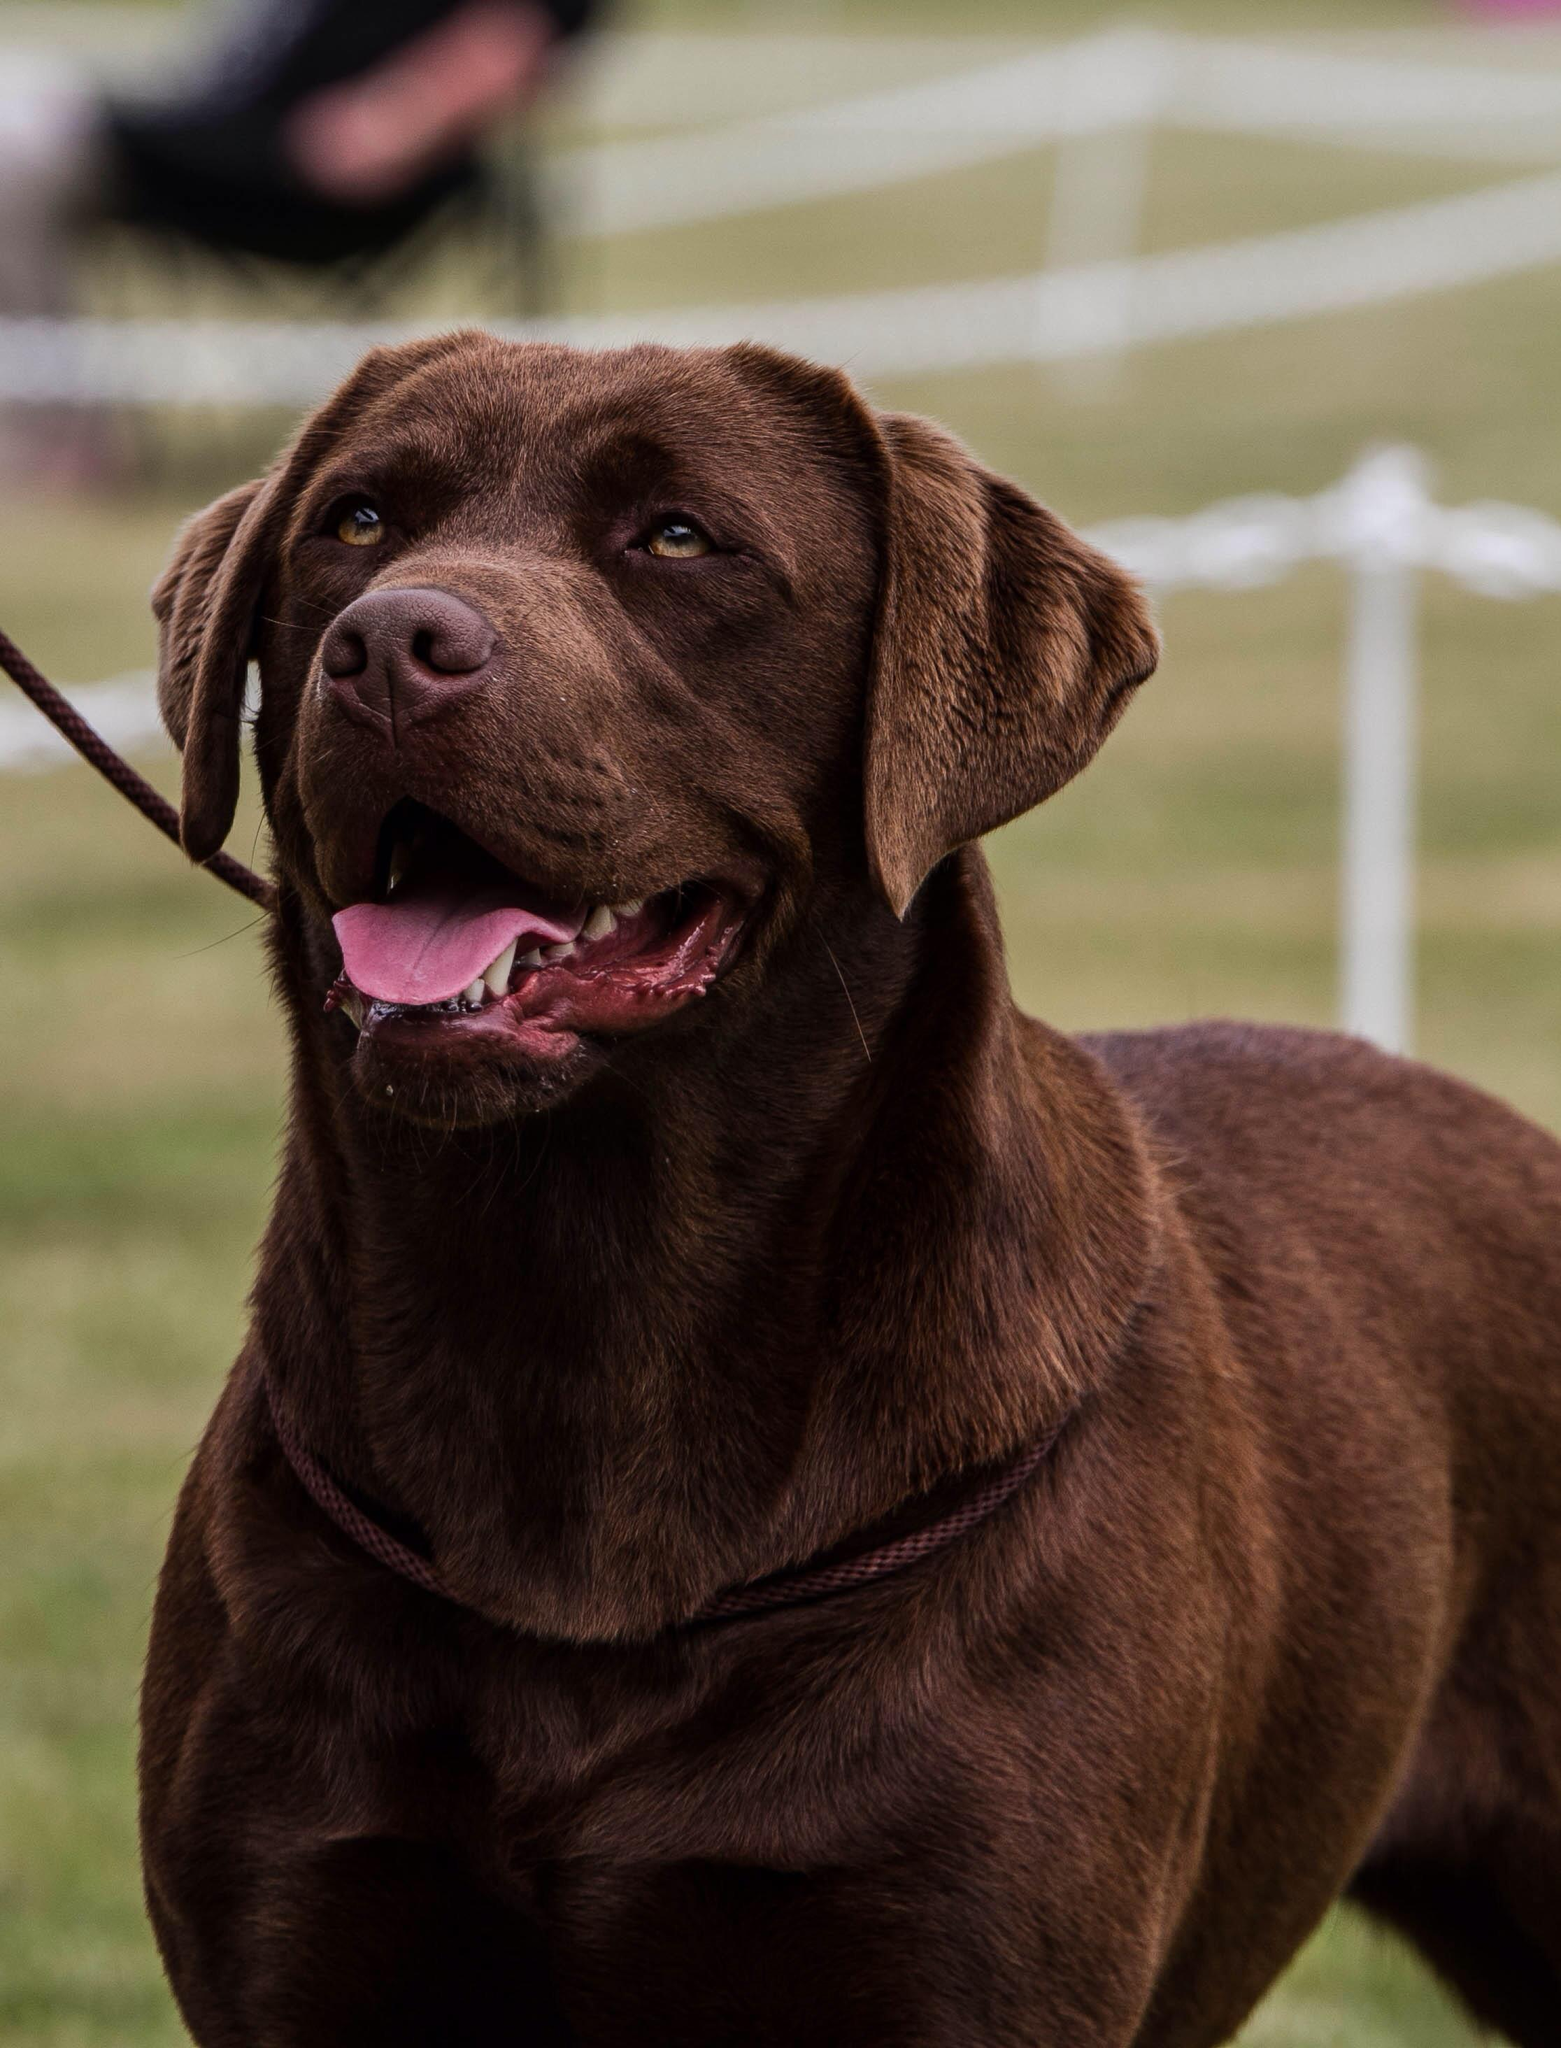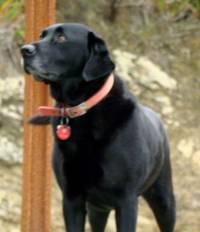The first image is the image on the left, the second image is the image on the right. Analyze the images presented: Is the assertion "A large brown colored dog is outside." valid? Answer yes or no. Yes. The first image is the image on the left, the second image is the image on the right. Evaluate the accuracy of this statement regarding the images: "One of the images shows a black labrador and the other shows a brown labrador.". Is it true? Answer yes or no. Yes. 